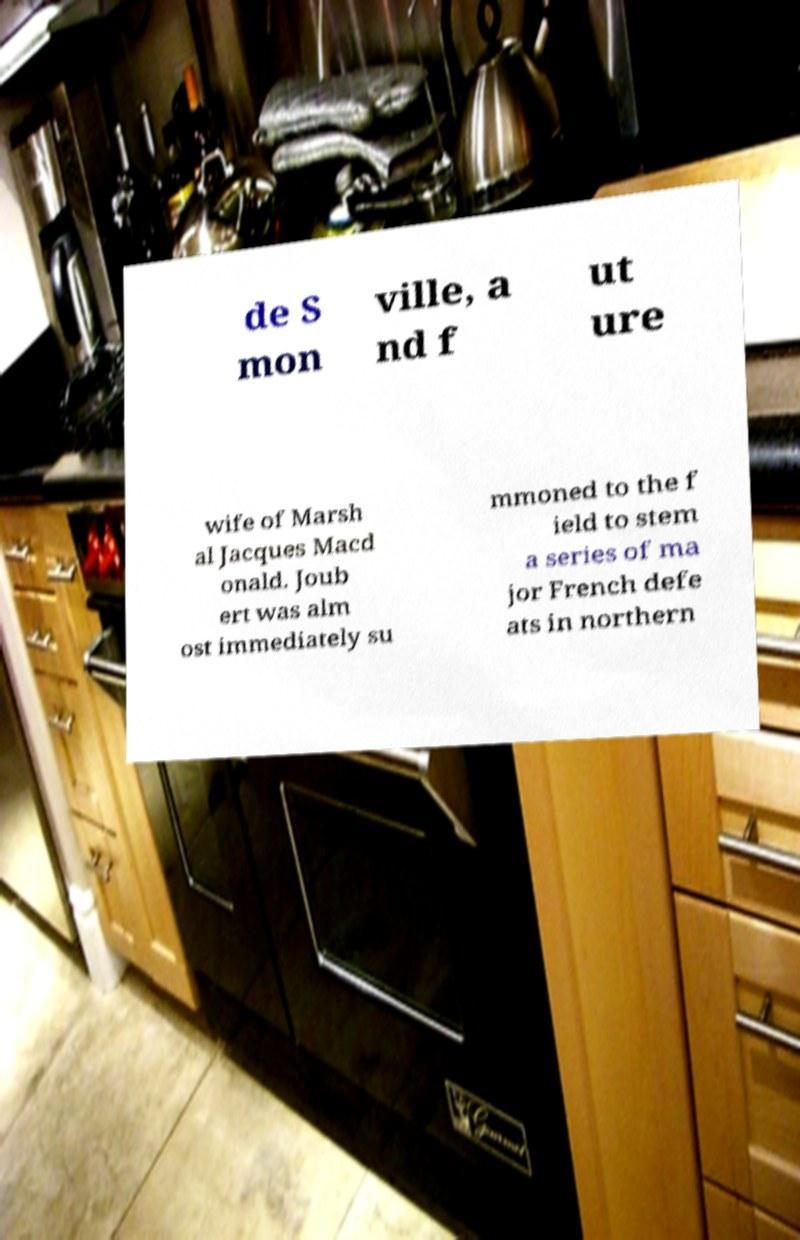Can you read and provide the text displayed in the image?This photo seems to have some interesting text. Can you extract and type it out for me? de S mon ville, a nd f ut ure wife of Marsh al Jacques Macd onald. Joub ert was alm ost immediately su mmoned to the f ield to stem a series of ma jor French defe ats in northern 